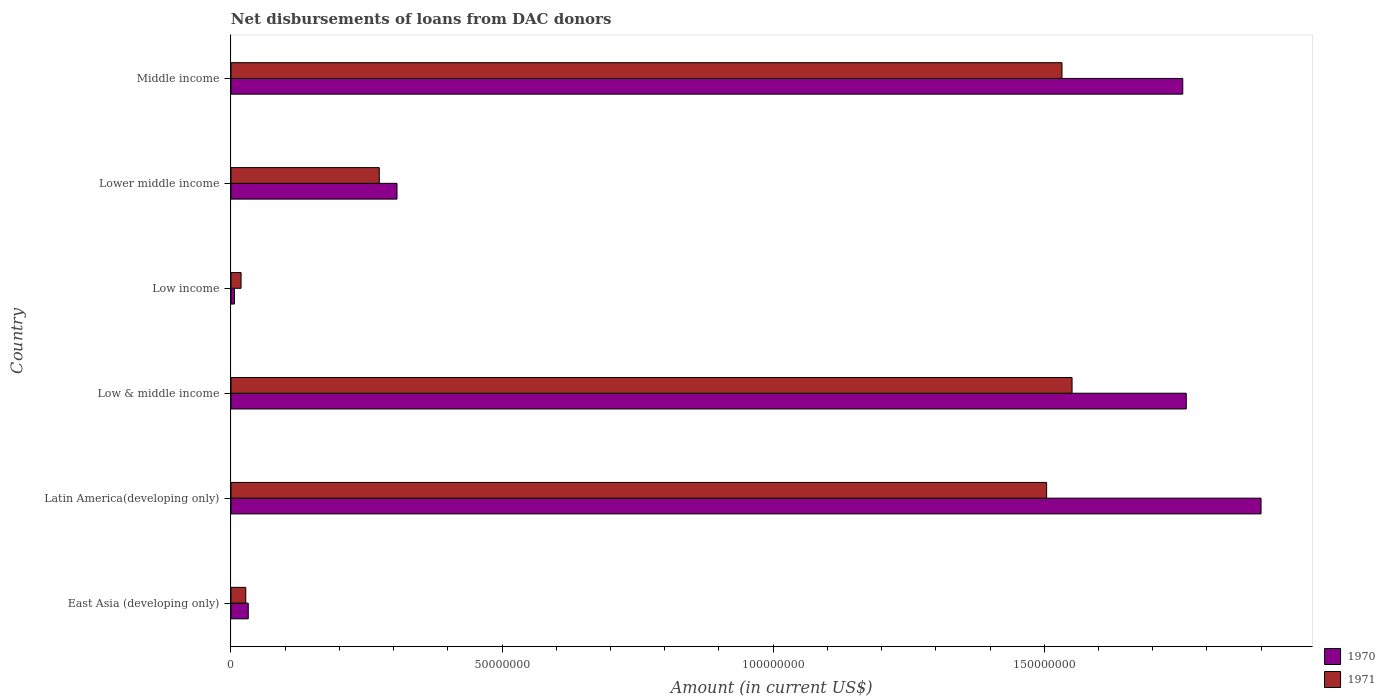How many different coloured bars are there?
Provide a short and direct response. 2. How many groups of bars are there?
Ensure brevity in your answer.  6. Are the number of bars on each tick of the Y-axis equal?
Make the answer very short. Yes. What is the label of the 3rd group of bars from the top?
Ensure brevity in your answer.  Low income. In how many cases, is the number of bars for a given country not equal to the number of legend labels?
Offer a very short reply. 0. What is the amount of loans disbursed in 1970 in Low income?
Make the answer very short. 6.47e+05. Across all countries, what is the maximum amount of loans disbursed in 1970?
Make the answer very short. 1.90e+08. Across all countries, what is the minimum amount of loans disbursed in 1971?
Offer a very short reply. 1.86e+06. In which country was the amount of loans disbursed in 1971 maximum?
Provide a succinct answer. Low & middle income. In which country was the amount of loans disbursed in 1970 minimum?
Ensure brevity in your answer.  Low income. What is the total amount of loans disbursed in 1970 in the graph?
Make the answer very short. 5.76e+08. What is the difference between the amount of loans disbursed in 1970 in Low & middle income and that in Middle income?
Make the answer very short. 6.47e+05. What is the difference between the amount of loans disbursed in 1971 in Lower middle income and the amount of loans disbursed in 1970 in Middle income?
Ensure brevity in your answer.  -1.48e+08. What is the average amount of loans disbursed in 1970 per country?
Provide a succinct answer. 9.60e+07. What is the difference between the amount of loans disbursed in 1970 and amount of loans disbursed in 1971 in Middle income?
Your answer should be compact. 2.23e+07. What is the ratio of the amount of loans disbursed in 1971 in Low & middle income to that in Low income?
Your response must be concise. 83.45. Is the amount of loans disbursed in 1970 in Lower middle income less than that in Middle income?
Offer a terse response. Yes. Is the difference between the amount of loans disbursed in 1970 in Latin America(developing only) and Low income greater than the difference between the amount of loans disbursed in 1971 in Latin America(developing only) and Low income?
Keep it short and to the point. Yes. What is the difference between the highest and the second highest amount of loans disbursed in 1971?
Keep it short and to the point. 1.86e+06. What is the difference between the highest and the lowest amount of loans disbursed in 1970?
Keep it short and to the point. 1.89e+08. What does the 1st bar from the bottom in Latin America(developing only) represents?
Offer a terse response. 1970. Does the graph contain any zero values?
Make the answer very short. No. Does the graph contain grids?
Your answer should be very brief. No. How many legend labels are there?
Give a very brief answer. 2. What is the title of the graph?
Keep it short and to the point. Net disbursements of loans from DAC donors. Does "2000" appear as one of the legend labels in the graph?
Your response must be concise. No. What is the Amount (in current US$) in 1970 in East Asia (developing only)?
Give a very brief answer. 3.19e+06. What is the Amount (in current US$) of 1971 in East Asia (developing only)?
Ensure brevity in your answer.  2.73e+06. What is the Amount (in current US$) of 1970 in Latin America(developing only)?
Offer a terse response. 1.90e+08. What is the Amount (in current US$) in 1971 in Latin America(developing only)?
Your response must be concise. 1.50e+08. What is the Amount (in current US$) in 1970 in Low & middle income?
Your response must be concise. 1.76e+08. What is the Amount (in current US$) in 1971 in Low & middle income?
Make the answer very short. 1.55e+08. What is the Amount (in current US$) in 1970 in Low income?
Keep it short and to the point. 6.47e+05. What is the Amount (in current US$) in 1971 in Low income?
Provide a short and direct response. 1.86e+06. What is the Amount (in current US$) of 1970 in Lower middle income?
Your response must be concise. 3.06e+07. What is the Amount (in current US$) of 1971 in Lower middle income?
Give a very brief answer. 2.74e+07. What is the Amount (in current US$) in 1970 in Middle income?
Your answer should be very brief. 1.76e+08. What is the Amount (in current US$) of 1971 in Middle income?
Ensure brevity in your answer.  1.53e+08. Across all countries, what is the maximum Amount (in current US$) of 1970?
Provide a succinct answer. 1.90e+08. Across all countries, what is the maximum Amount (in current US$) of 1971?
Give a very brief answer. 1.55e+08. Across all countries, what is the minimum Amount (in current US$) of 1970?
Offer a terse response. 6.47e+05. Across all countries, what is the minimum Amount (in current US$) in 1971?
Your answer should be compact. 1.86e+06. What is the total Amount (in current US$) of 1970 in the graph?
Provide a succinct answer. 5.76e+08. What is the total Amount (in current US$) in 1971 in the graph?
Your response must be concise. 4.91e+08. What is the difference between the Amount (in current US$) of 1970 in East Asia (developing only) and that in Latin America(developing only)?
Offer a very short reply. -1.87e+08. What is the difference between the Amount (in current US$) in 1971 in East Asia (developing only) and that in Latin America(developing only)?
Ensure brevity in your answer.  -1.48e+08. What is the difference between the Amount (in current US$) of 1970 in East Asia (developing only) and that in Low & middle income?
Your response must be concise. -1.73e+08. What is the difference between the Amount (in current US$) in 1971 in East Asia (developing only) and that in Low & middle income?
Provide a succinct answer. -1.52e+08. What is the difference between the Amount (in current US$) in 1970 in East Asia (developing only) and that in Low income?
Offer a terse response. 2.54e+06. What is the difference between the Amount (in current US$) in 1971 in East Asia (developing only) and that in Low income?
Provide a short and direct response. 8.69e+05. What is the difference between the Amount (in current US$) of 1970 in East Asia (developing only) and that in Lower middle income?
Keep it short and to the point. -2.74e+07. What is the difference between the Amount (in current US$) of 1971 in East Asia (developing only) and that in Lower middle income?
Your answer should be very brief. -2.46e+07. What is the difference between the Amount (in current US$) in 1970 in East Asia (developing only) and that in Middle income?
Provide a short and direct response. -1.72e+08. What is the difference between the Amount (in current US$) in 1971 in East Asia (developing only) and that in Middle income?
Keep it short and to the point. -1.51e+08. What is the difference between the Amount (in current US$) of 1970 in Latin America(developing only) and that in Low & middle income?
Provide a succinct answer. 1.38e+07. What is the difference between the Amount (in current US$) of 1971 in Latin America(developing only) and that in Low & middle income?
Offer a terse response. -4.69e+06. What is the difference between the Amount (in current US$) in 1970 in Latin America(developing only) and that in Low income?
Your answer should be compact. 1.89e+08. What is the difference between the Amount (in current US$) in 1971 in Latin America(developing only) and that in Low income?
Offer a terse response. 1.49e+08. What is the difference between the Amount (in current US$) of 1970 in Latin America(developing only) and that in Lower middle income?
Your response must be concise. 1.59e+08. What is the difference between the Amount (in current US$) of 1971 in Latin America(developing only) and that in Lower middle income?
Provide a succinct answer. 1.23e+08. What is the difference between the Amount (in current US$) in 1970 in Latin America(developing only) and that in Middle income?
Offer a terse response. 1.44e+07. What is the difference between the Amount (in current US$) of 1971 in Latin America(developing only) and that in Middle income?
Offer a terse response. -2.84e+06. What is the difference between the Amount (in current US$) of 1970 in Low & middle income and that in Low income?
Give a very brief answer. 1.76e+08. What is the difference between the Amount (in current US$) in 1971 in Low & middle income and that in Low income?
Provide a succinct answer. 1.53e+08. What is the difference between the Amount (in current US$) in 1970 in Low & middle income and that in Lower middle income?
Your answer should be very brief. 1.46e+08. What is the difference between the Amount (in current US$) of 1971 in Low & middle income and that in Lower middle income?
Provide a short and direct response. 1.28e+08. What is the difference between the Amount (in current US$) of 1970 in Low & middle income and that in Middle income?
Offer a terse response. 6.47e+05. What is the difference between the Amount (in current US$) of 1971 in Low & middle income and that in Middle income?
Keep it short and to the point. 1.86e+06. What is the difference between the Amount (in current US$) of 1970 in Low income and that in Lower middle income?
Ensure brevity in your answer.  -3.00e+07. What is the difference between the Amount (in current US$) in 1971 in Low income and that in Lower middle income?
Your response must be concise. -2.55e+07. What is the difference between the Amount (in current US$) of 1970 in Low income and that in Middle income?
Your answer should be very brief. -1.75e+08. What is the difference between the Amount (in current US$) of 1971 in Low income and that in Middle income?
Offer a terse response. -1.51e+08. What is the difference between the Amount (in current US$) of 1970 in Lower middle income and that in Middle income?
Provide a succinct answer. -1.45e+08. What is the difference between the Amount (in current US$) in 1971 in Lower middle income and that in Middle income?
Keep it short and to the point. -1.26e+08. What is the difference between the Amount (in current US$) in 1970 in East Asia (developing only) and the Amount (in current US$) in 1971 in Latin America(developing only)?
Keep it short and to the point. -1.47e+08. What is the difference between the Amount (in current US$) of 1970 in East Asia (developing only) and the Amount (in current US$) of 1971 in Low & middle income?
Offer a very short reply. -1.52e+08. What is the difference between the Amount (in current US$) in 1970 in East Asia (developing only) and the Amount (in current US$) in 1971 in Low income?
Give a very brief answer. 1.33e+06. What is the difference between the Amount (in current US$) of 1970 in East Asia (developing only) and the Amount (in current US$) of 1971 in Lower middle income?
Provide a succinct answer. -2.42e+07. What is the difference between the Amount (in current US$) in 1970 in East Asia (developing only) and the Amount (in current US$) in 1971 in Middle income?
Ensure brevity in your answer.  -1.50e+08. What is the difference between the Amount (in current US$) of 1970 in Latin America(developing only) and the Amount (in current US$) of 1971 in Low & middle income?
Keep it short and to the point. 3.49e+07. What is the difference between the Amount (in current US$) in 1970 in Latin America(developing only) and the Amount (in current US$) in 1971 in Low income?
Ensure brevity in your answer.  1.88e+08. What is the difference between the Amount (in current US$) in 1970 in Latin America(developing only) and the Amount (in current US$) in 1971 in Lower middle income?
Offer a very short reply. 1.63e+08. What is the difference between the Amount (in current US$) in 1970 in Latin America(developing only) and the Amount (in current US$) in 1971 in Middle income?
Offer a very short reply. 3.67e+07. What is the difference between the Amount (in current US$) in 1970 in Low & middle income and the Amount (in current US$) in 1971 in Low income?
Offer a very short reply. 1.74e+08. What is the difference between the Amount (in current US$) of 1970 in Low & middle income and the Amount (in current US$) of 1971 in Lower middle income?
Your answer should be very brief. 1.49e+08. What is the difference between the Amount (in current US$) in 1970 in Low & middle income and the Amount (in current US$) in 1971 in Middle income?
Your answer should be very brief. 2.29e+07. What is the difference between the Amount (in current US$) of 1970 in Low income and the Amount (in current US$) of 1971 in Lower middle income?
Make the answer very short. -2.67e+07. What is the difference between the Amount (in current US$) in 1970 in Low income and the Amount (in current US$) in 1971 in Middle income?
Ensure brevity in your answer.  -1.53e+08. What is the difference between the Amount (in current US$) in 1970 in Lower middle income and the Amount (in current US$) in 1971 in Middle income?
Your answer should be compact. -1.23e+08. What is the average Amount (in current US$) in 1970 per country?
Provide a short and direct response. 9.60e+07. What is the average Amount (in current US$) of 1971 per country?
Ensure brevity in your answer.  8.18e+07. What is the difference between the Amount (in current US$) in 1970 and Amount (in current US$) in 1971 in East Asia (developing only)?
Give a very brief answer. 4.61e+05. What is the difference between the Amount (in current US$) in 1970 and Amount (in current US$) in 1971 in Latin America(developing only)?
Provide a succinct answer. 3.96e+07. What is the difference between the Amount (in current US$) of 1970 and Amount (in current US$) of 1971 in Low & middle income?
Provide a short and direct response. 2.11e+07. What is the difference between the Amount (in current US$) of 1970 and Amount (in current US$) of 1971 in Low income?
Provide a short and direct response. -1.21e+06. What is the difference between the Amount (in current US$) of 1970 and Amount (in current US$) of 1971 in Lower middle income?
Your answer should be compact. 3.27e+06. What is the difference between the Amount (in current US$) of 1970 and Amount (in current US$) of 1971 in Middle income?
Your answer should be very brief. 2.23e+07. What is the ratio of the Amount (in current US$) of 1970 in East Asia (developing only) to that in Latin America(developing only)?
Offer a very short reply. 0.02. What is the ratio of the Amount (in current US$) in 1971 in East Asia (developing only) to that in Latin America(developing only)?
Your answer should be very brief. 0.02. What is the ratio of the Amount (in current US$) in 1970 in East Asia (developing only) to that in Low & middle income?
Keep it short and to the point. 0.02. What is the ratio of the Amount (in current US$) in 1971 in East Asia (developing only) to that in Low & middle income?
Offer a terse response. 0.02. What is the ratio of the Amount (in current US$) in 1970 in East Asia (developing only) to that in Low income?
Your answer should be very brief. 4.93. What is the ratio of the Amount (in current US$) in 1971 in East Asia (developing only) to that in Low income?
Provide a short and direct response. 1.47. What is the ratio of the Amount (in current US$) of 1970 in East Asia (developing only) to that in Lower middle income?
Your answer should be compact. 0.1. What is the ratio of the Amount (in current US$) in 1971 in East Asia (developing only) to that in Lower middle income?
Ensure brevity in your answer.  0.1. What is the ratio of the Amount (in current US$) in 1970 in East Asia (developing only) to that in Middle income?
Give a very brief answer. 0.02. What is the ratio of the Amount (in current US$) of 1971 in East Asia (developing only) to that in Middle income?
Your response must be concise. 0.02. What is the ratio of the Amount (in current US$) in 1970 in Latin America(developing only) to that in Low & middle income?
Give a very brief answer. 1.08. What is the ratio of the Amount (in current US$) of 1971 in Latin America(developing only) to that in Low & middle income?
Provide a succinct answer. 0.97. What is the ratio of the Amount (in current US$) of 1970 in Latin America(developing only) to that in Low income?
Offer a terse response. 293.65. What is the ratio of the Amount (in current US$) of 1971 in Latin America(developing only) to that in Low income?
Provide a succinct answer. 80.93. What is the ratio of the Amount (in current US$) in 1970 in Latin America(developing only) to that in Lower middle income?
Provide a short and direct response. 6.2. What is the ratio of the Amount (in current US$) of 1971 in Latin America(developing only) to that in Lower middle income?
Provide a short and direct response. 5.5. What is the ratio of the Amount (in current US$) in 1970 in Latin America(developing only) to that in Middle income?
Provide a succinct answer. 1.08. What is the ratio of the Amount (in current US$) in 1971 in Latin America(developing only) to that in Middle income?
Your answer should be compact. 0.98. What is the ratio of the Amount (in current US$) of 1970 in Low & middle income to that in Low income?
Provide a short and direct response. 272.33. What is the ratio of the Amount (in current US$) of 1971 in Low & middle income to that in Low income?
Offer a terse response. 83.45. What is the ratio of the Amount (in current US$) of 1970 in Low & middle income to that in Lower middle income?
Keep it short and to the point. 5.75. What is the ratio of the Amount (in current US$) in 1971 in Low & middle income to that in Lower middle income?
Provide a short and direct response. 5.67. What is the ratio of the Amount (in current US$) of 1971 in Low & middle income to that in Middle income?
Provide a short and direct response. 1.01. What is the ratio of the Amount (in current US$) of 1970 in Low income to that in Lower middle income?
Offer a terse response. 0.02. What is the ratio of the Amount (in current US$) of 1971 in Low income to that in Lower middle income?
Offer a very short reply. 0.07. What is the ratio of the Amount (in current US$) of 1970 in Low income to that in Middle income?
Your answer should be very brief. 0. What is the ratio of the Amount (in current US$) of 1971 in Low income to that in Middle income?
Provide a succinct answer. 0.01. What is the ratio of the Amount (in current US$) in 1970 in Lower middle income to that in Middle income?
Your answer should be very brief. 0.17. What is the ratio of the Amount (in current US$) in 1971 in Lower middle income to that in Middle income?
Make the answer very short. 0.18. What is the difference between the highest and the second highest Amount (in current US$) in 1970?
Provide a short and direct response. 1.38e+07. What is the difference between the highest and the second highest Amount (in current US$) of 1971?
Make the answer very short. 1.86e+06. What is the difference between the highest and the lowest Amount (in current US$) of 1970?
Give a very brief answer. 1.89e+08. What is the difference between the highest and the lowest Amount (in current US$) in 1971?
Ensure brevity in your answer.  1.53e+08. 